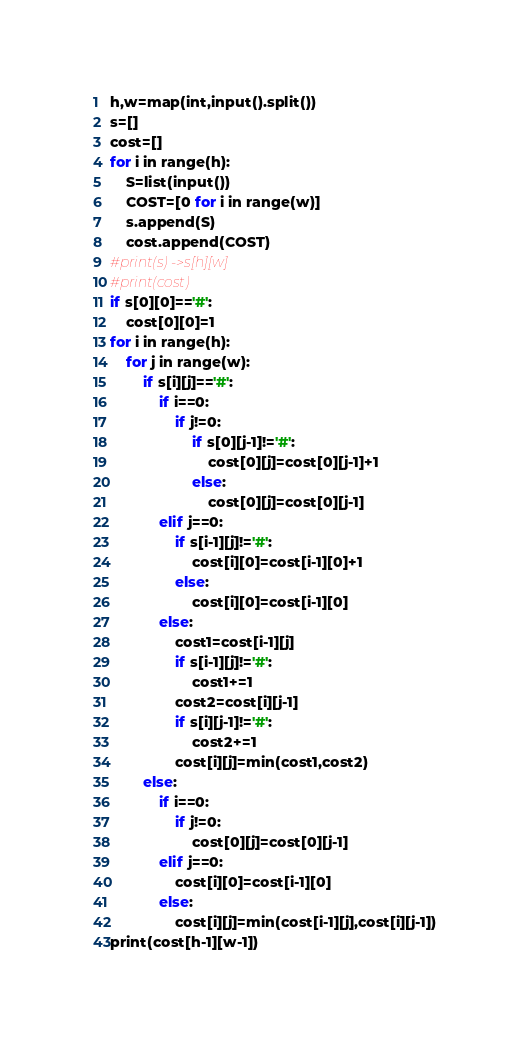Convert code to text. <code><loc_0><loc_0><loc_500><loc_500><_Python_>h,w=map(int,input().split())
s=[]
cost=[]
for i in range(h):
	S=list(input())
	COST=[0 for i in range(w)]
	s.append(S)
	cost.append(COST)
#print(s) ->s[h][w]
#print(cost)
if s[0][0]=='#':
	cost[0][0]=1
for i in range(h):
	for j in range(w):
		if s[i][j]=='#':
			if i==0:
				if j!=0:
					if s[0][j-1]!='#':
						cost[0][j]=cost[0][j-1]+1
					else:
						cost[0][j]=cost[0][j-1]
			elif j==0:
				if s[i-1][j]!='#':
					cost[i][0]=cost[i-1][0]+1
				else:
					cost[i][0]=cost[i-1][0]
			else:
				cost1=cost[i-1][j]
				if s[i-1][j]!='#':
					cost1+=1
				cost2=cost[i][j-1]
				if s[i][j-1]!='#':
					cost2+=1
				cost[i][j]=min(cost1,cost2)
		else:
			if i==0:
				if j!=0:
					cost[0][j]=cost[0][j-1]
			elif j==0:
				cost[i][0]=cost[i-1][0]
			else:
				cost[i][j]=min(cost[i-1][j],cost[i][j-1])
print(cost[h-1][w-1])</code> 